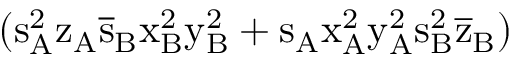Convert formula to latex. <formula><loc_0><loc_0><loc_500><loc_500>( s _ { A } ^ { 2 } \mathrm { z _ { A } \mathrm { \overline { s } _ { B } \mathrm { x _ { B } ^ { 2 } \mathrm { y _ { B } ^ { 2 } + \mathrm { s _ { A } \mathrm { x _ { A } ^ { 2 } \mathrm { y _ { A } ^ { 2 } \mathrm { s _ { B } ^ { 2 } \mathrm { \overline { z } _ { B } ) } } } } } } } } }</formula> 